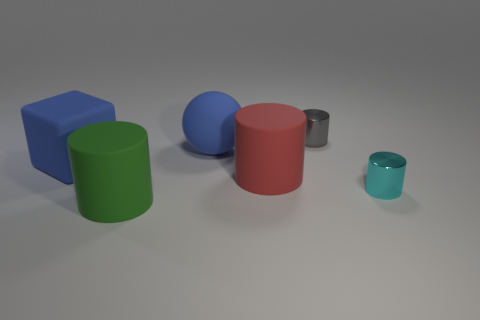Subtract all red rubber cylinders. How many cylinders are left? 3 Add 1 red matte cylinders. How many objects exist? 7 Subtract all red cylinders. How many cylinders are left? 3 Subtract all cylinders. How many objects are left? 2 Subtract 0 red spheres. How many objects are left? 6 Subtract 4 cylinders. How many cylinders are left? 0 Subtract all green cylinders. Subtract all red blocks. How many cylinders are left? 3 Subtract all red balls. How many red cylinders are left? 1 Subtract all cyan cylinders. Subtract all green matte things. How many objects are left? 4 Add 4 red rubber cylinders. How many red rubber cylinders are left? 5 